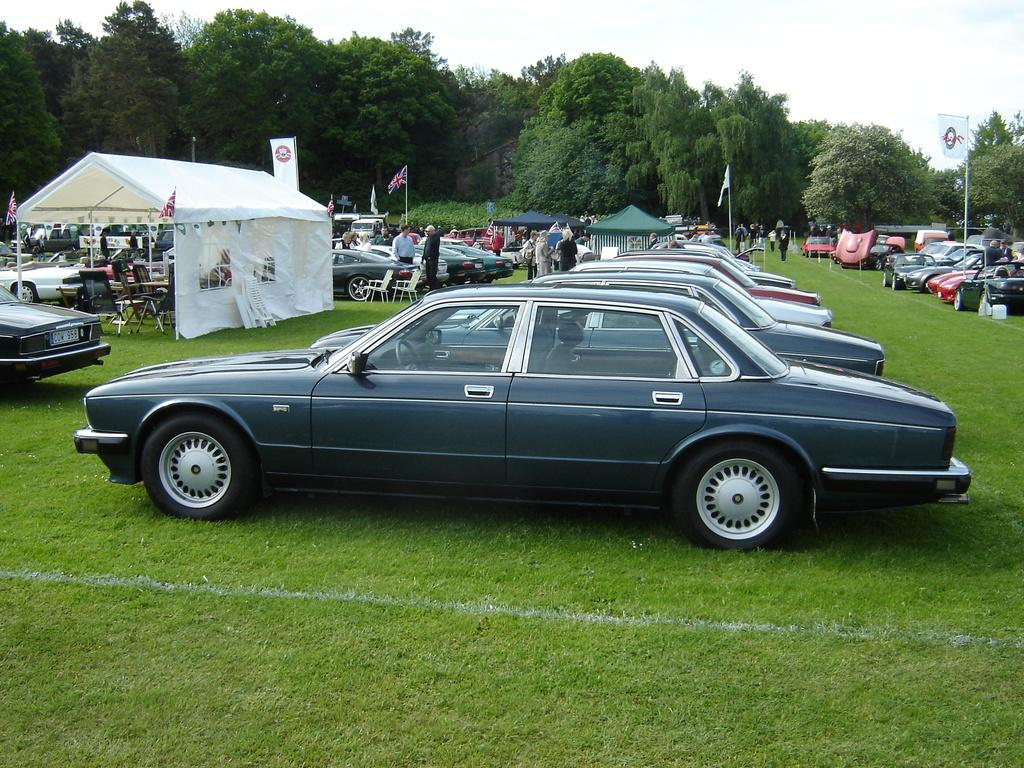What types of objects are present in the image? There are vehicles and people in the image. What can be seen in the background of the image? In the background, there are tents, chairs, flags, trees, and some unspecified objects. What is visible in the sky in the image? The sky is visible in the background of the image. What type of fiction is being attempted by the people in the image? There is no indication in the image that the people are attempting any type of fiction. 